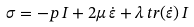<formula> <loc_0><loc_0><loc_500><loc_500>\, { \sigma } = - p \, { I } + 2 \mu \, { \dot { \varepsilon } } + \lambda \, { t r } ( { \dot { \varepsilon } } ) \, { I } \,</formula> 